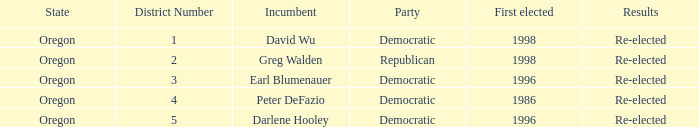Which district has a Democratic incumbent that was first elected before 1996? Oregon 4. 